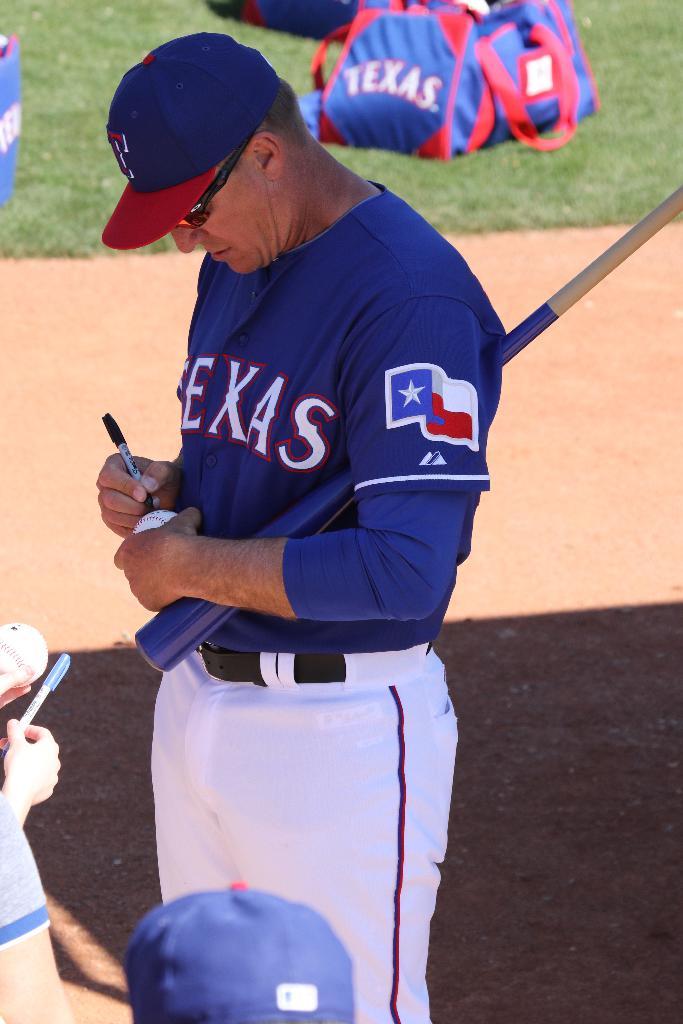What state is on his jersey?
Ensure brevity in your answer.  Texas. What letter is on his hat?
Your answer should be very brief. T. 